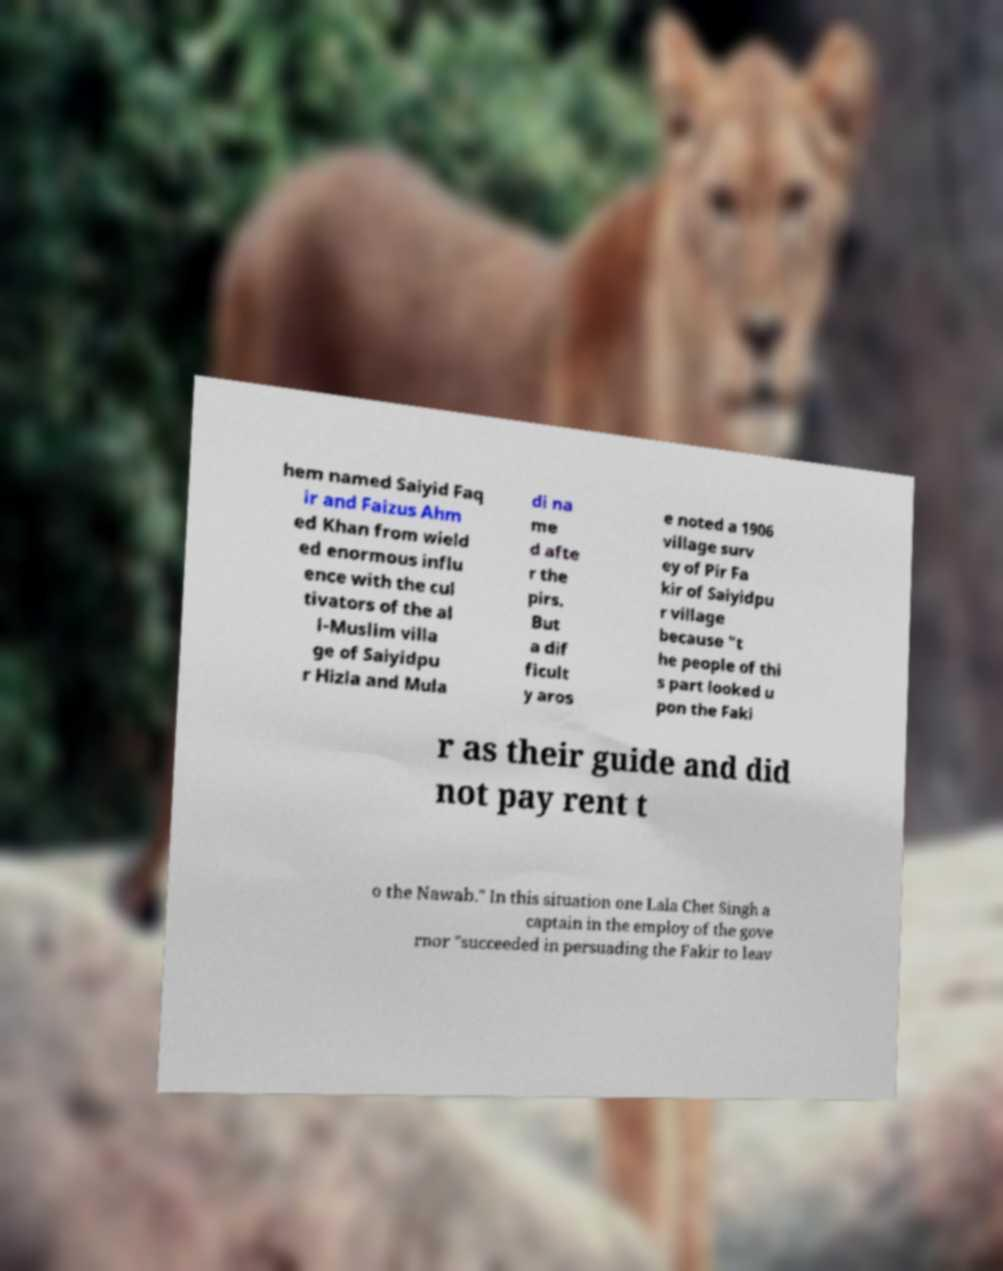For documentation purposes, I need the text within this image transcribed. Could you provide that? hem named Saiyid Faq ir and Faizus Ahm ed Khan from wield ed enormous influ ence with the cul tivators of the al l-Muslim villa ge of Saiyidpu r Hizla and Mula di na me d afte r the pirs. But a dif ficult y aros e noted a 1906 village surv ey of Pir Fa kir of Saiyidpu r village because "t he people of thi s part looked u pon the Faki r as their guide and did not pay rent t o the Nawab." In this situation one Lala Chet Singh a captain in the employ of the gove rnor "succeeded in persuading the Fakir to leav 